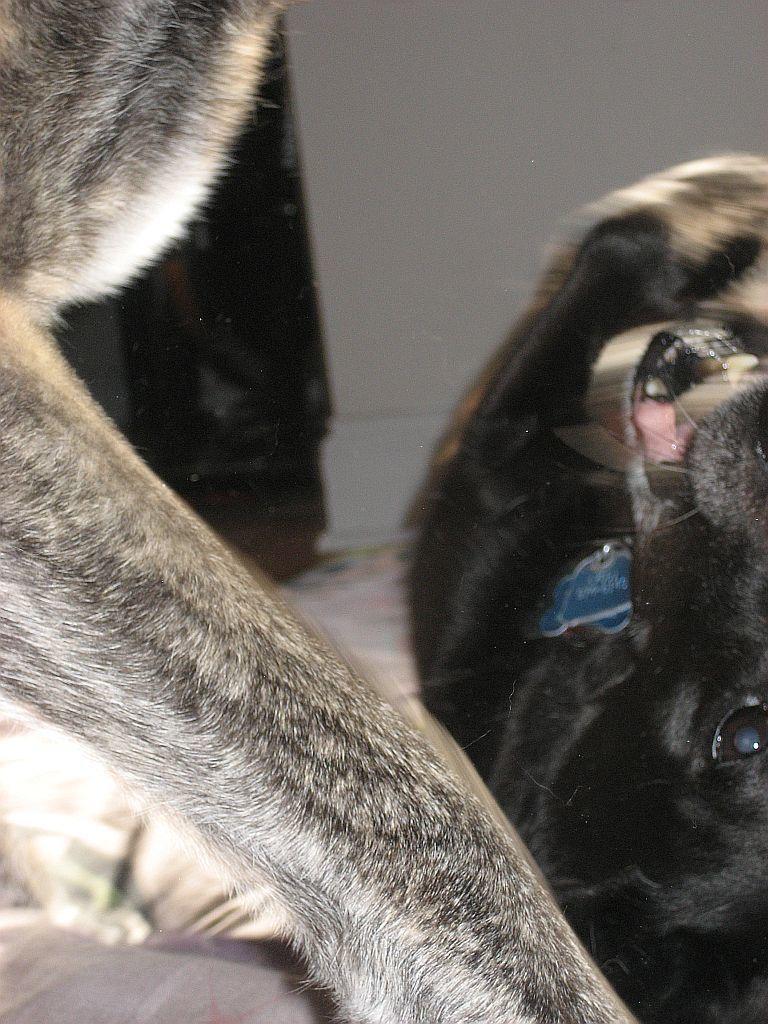Could you give a brief overview of what you see in this image? In this image there is a dog and a leg of another dog. 